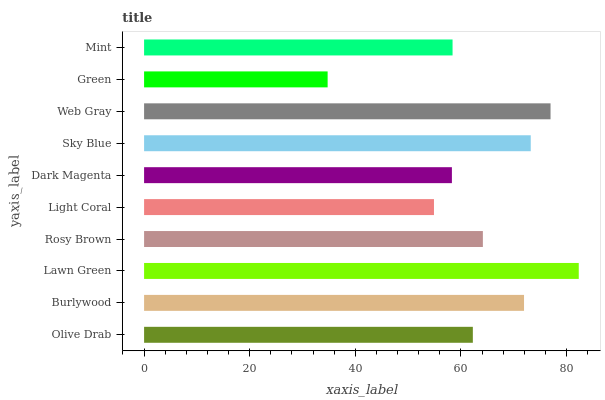Is Green the minimum?
Answer yes or no. Yes. Is Lawn Green the maximum?
Answer yes or no. Yes. Is Burlywood the minimum?
Answer yes or no. No. Is Burlywood the maximum?
Answer yes or no. No. Is Burlywood greater than Olive Drab?
Answer yes or no. Yes. Is Olive Drab less than Burlywood?
Answer yes or no. Yes. Is Olive Drab greater than Burlywood?
Answer yes or no. No. Is Burlywood less than Olive Drab?
Answer yes or no. No. Is Rosy Brown the high median?
Answer yes or no. Yes. Is Olive Drab the low median?
Answer yes or no. Yes. Is Green the high median?
Answer yes or no. No. Is Sky Blue the low median?
Answer yes or no. No. 